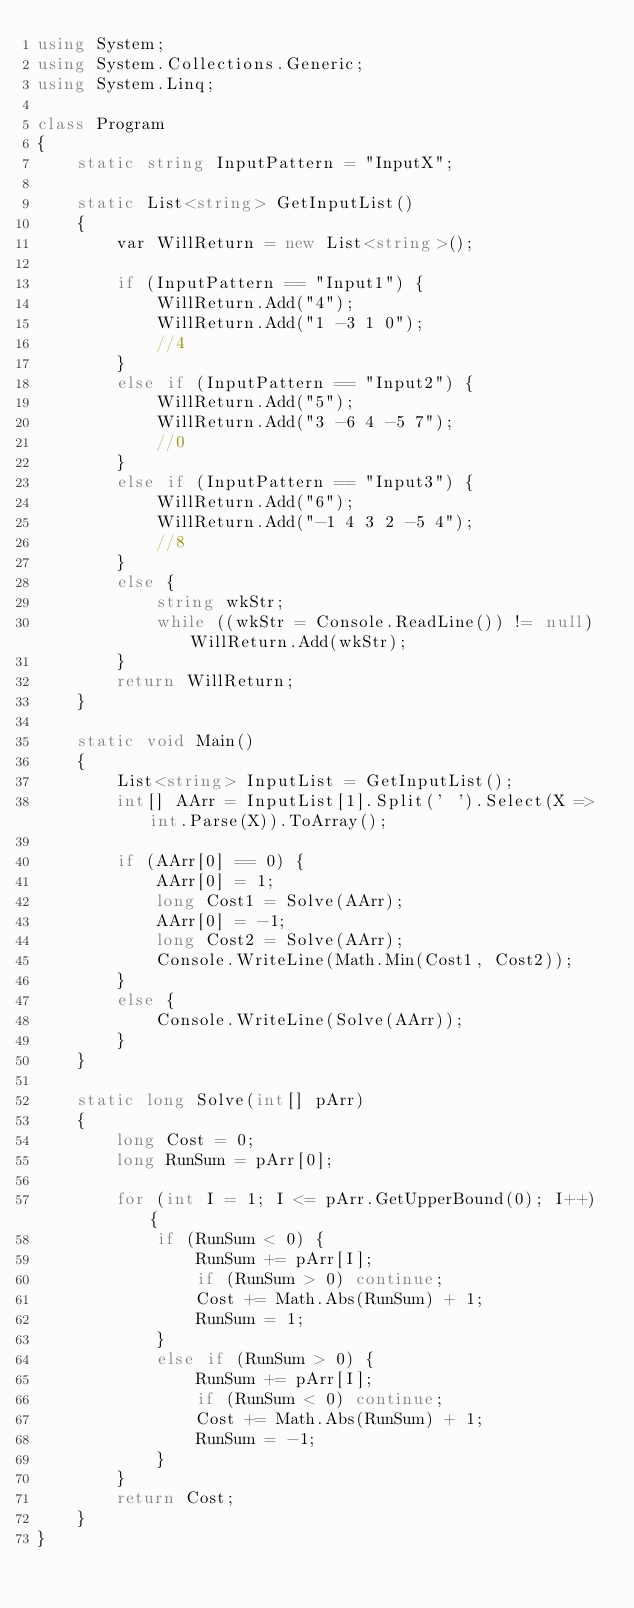Convert code to text. <code><loc_0><loc_0><loc_500><loc_500><_C#_>using System;
using System.Collections.Generic;
using System.Linq;

class Program
{
    static string InputPattern = "InputX";

    static List<string> GetInputList()
    {
        var WillReturn = new List<string>();

        if (InputPattern == "Input1") {
            WillReturn.Add("4");
            WillReturn.Add("1 -3 1 0");
            //4
        }
        else if (InputPattern == "Input2") {
            WillReturn.Add("5");
            WillReturn.Add("3 -6 4 -5 7");
            //0
        }
        else if (InputPattern == "Input3") {
            WillReturn.Add("6");
            WillReturn.Add("-1 4 3 2 -5 4");
            //8
        }
        else {
            string wkStr;
            while ((wkStr = Console.ReadLine()) != null) WillReturn.Add(wkStr);
        }
        return WillReturn;
    }

    static void Main()
    {
        List<string> InputList = GetInputList();
        int[] AArr = InputList[1].Split(' ').Select(X => int.Parse(X)).ToArray();

        if (AArr[0] == 0) {
            AArr[0] = 1;
            long Cost1 = Solve(AArr);
            AArr[0] = -1;
            long Cost2 = Solve(AArr);
            Console.WriteLine(Math.Min(Cost1, Cost2));
        }
        else {
            Console.WriteLine(Solve(AArr));
        }
    }

    static long Solve(int[] pArr)
    {
        long Cost = 0;
        long RunSum = pArr[0];

        for (int I = 1; I <= pArr.GetUpperBound(0); I++) {
            if (RunSum < 0) {
                RunSum += pArr[I];
                if (RunSum > 0) continue;
                Cost += Math.Abs(RunSum) + 1;
                RunSum = 1;
            }
            else if (RunSum > 0) {
                RunSum += pArr[I];
                if (RunSum < 0) continue;
                Cost += Math.Abs(RunSum) + 1;
                RunSum = -1;
            }
        }
        return Cost;
    }
}
</code> 